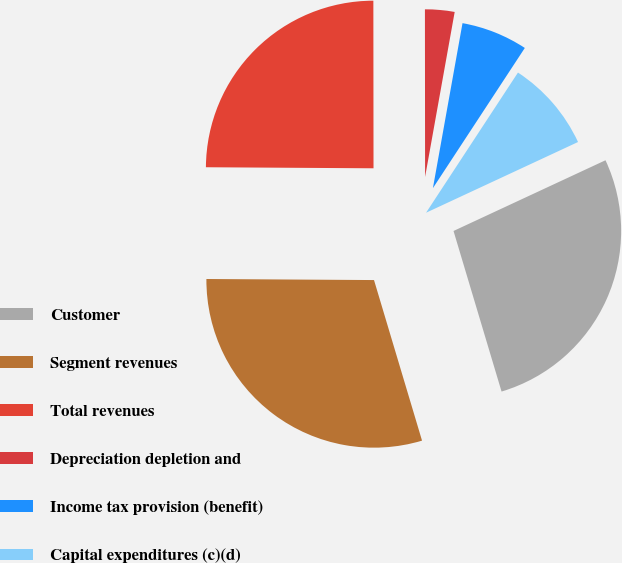Convert chart to OTSL. <chart><loc_0><loc_0><loc_500><loc_500><pie_chart><fcel>Customer<fcel>Segment revenues<fcel>Total revenues<fcel>Depreciation depletion and<fcel>Income tax provision (benefit)<fcel>Capital expenditures (c)(d)<nl><fcel>27.3%<fcel>29.72%<fcel>24.88%<fcel>2.84%<fcel>6.41%<fcel>8.83%<nl></chart> 